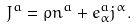Convert formula to latex. <formula><loc_0><loc_0><loc_500><loc_500>J ^ { a } = \rho n ^ { a } + e ^ { a } _ { \alpha } j ^ { \alpha } .</formula> 